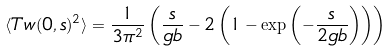<formula> <loc_0><loc_0><loc_500><loc_500>\langle T w ( 0 , s ) ^ { 2 } \rangle = \frac { 1 } { 3 \pi ^ { 2 } } \left ( \frac { s } { g b } - 2 \left ( 1 - \exp \left ( - \frac { s } { 2 g b } \right ) \right ) \right )</formula> 